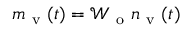<formula> <loc_0><loc_0><loc_500><loc_500>m _ { v } ( t ) = \mathcal { W } _ { o } n _ { v } ( t )</formula> 